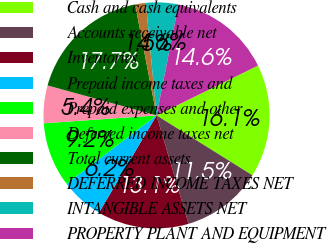Convert chart. <chart><loc_0><loc_0><loc_500><loc_500><pie_chart><fcel>Cash and cash equivalents<fcel>Accounts receivable net<fcel>Inventories<fcel>Prepaid income taxes and<fcel>Prepaid expenses and other<fcel>Deferred income taxes net<fcel>Total current assets<fcel>DEFERRED INCOME TAXES NET<fcel>INTANGIBLE ASSETS NET<fcel>PROPERTY PLANT AND EQUIPMENT<nl><fcel>16.15%<fcel>11.54%<fcel>13.08%<fcel>6.15%<fcel>9.23%<fcel>5.38%<fcel>17.69%<fcel>1.54%<fcel>4.62%<fcel>14.62%<nl></chart> 